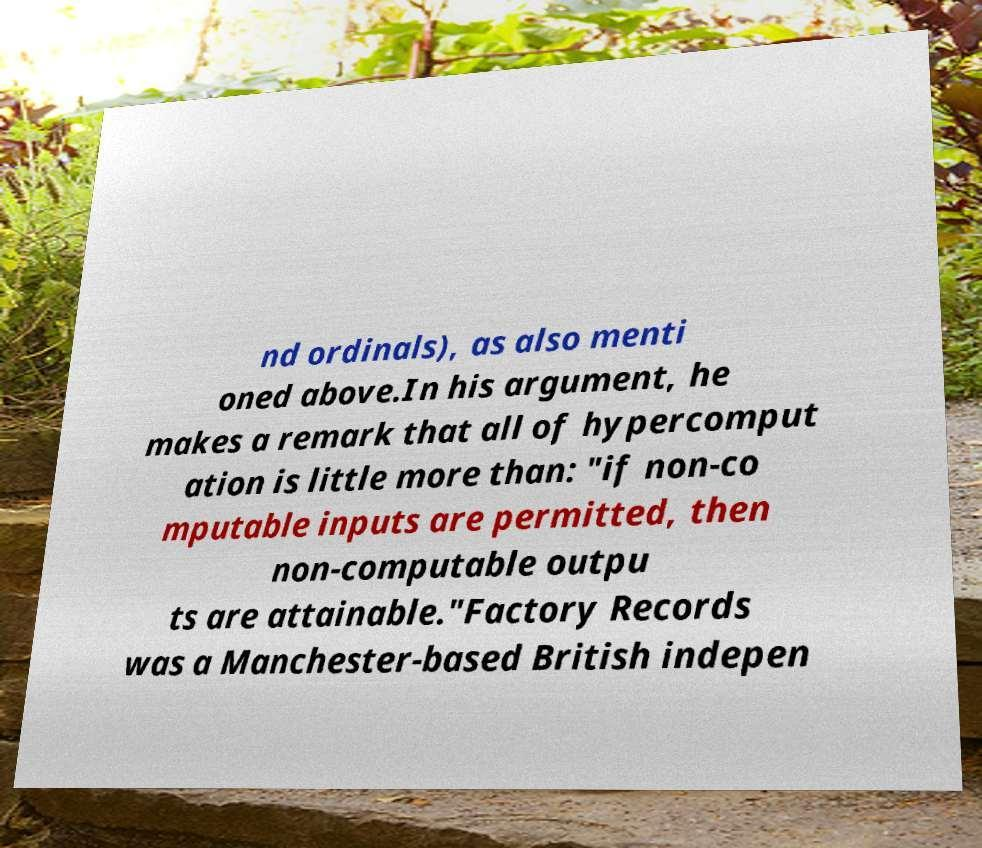What messages or text are displayed in this image? I need them in a readable, typed format. nd ordinals), as also menti oned above.In his argument, he makes a remark that all of hypercomput ation is little more than: "if non-co mputable inputs are permitted, then non-computable outpu ts are attainable."Factory Records was a Manchester-based British indepen 